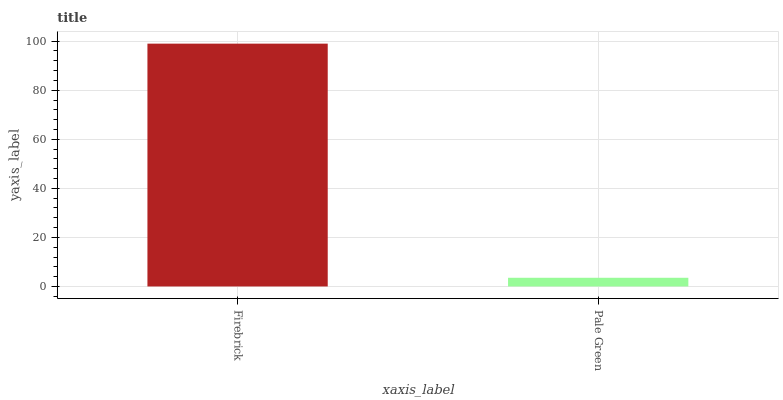Is Pale Green the minimum?
Answer yes or no. Yes. Is Firebrick the maximum?
Answer yes or no. Yes. Is Pale Green the maximum?
Answer yes or no. No. Is Firebrick greater than Pale Green?
Answer yes or no. Yes. Is Pale Green less than Firebrick?
Answer yes or no. Yes. Is Pale Green greater than Firebrick?
Answer yes or no. No. Is Firebrick less than Pale Green?
Answer yes or no. No. Is Firebrick the high median?
Answer yes or no. Yes. Is Pale Green the low median?
Answer yes or no. Yes. Is Pale Green the high median?
Answer yes or no. No. Is Firebrick the low median?
Answer yes or no. No. 